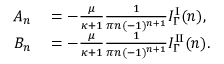<formula> <loc_0><loc_0><loc_500><loc_500>\begin{array} { r l } { A _ { n } } & = - \frac { \mu } { \kappa + 1 } \frac { 1 } { \pi n ( - 1 ) ^ { n + 1 } } I _ { \Gamma } ^ { I } ( n ) , } \\ { B _ { n } } & = - \frac { \mu } { \kappa + 1 } \frac { 1 } { \pi n ( - 1 ) ^ { n + 1 } } I _ { \Gamma } ^ { I I } ( n ) . } \end{array}</formula> 